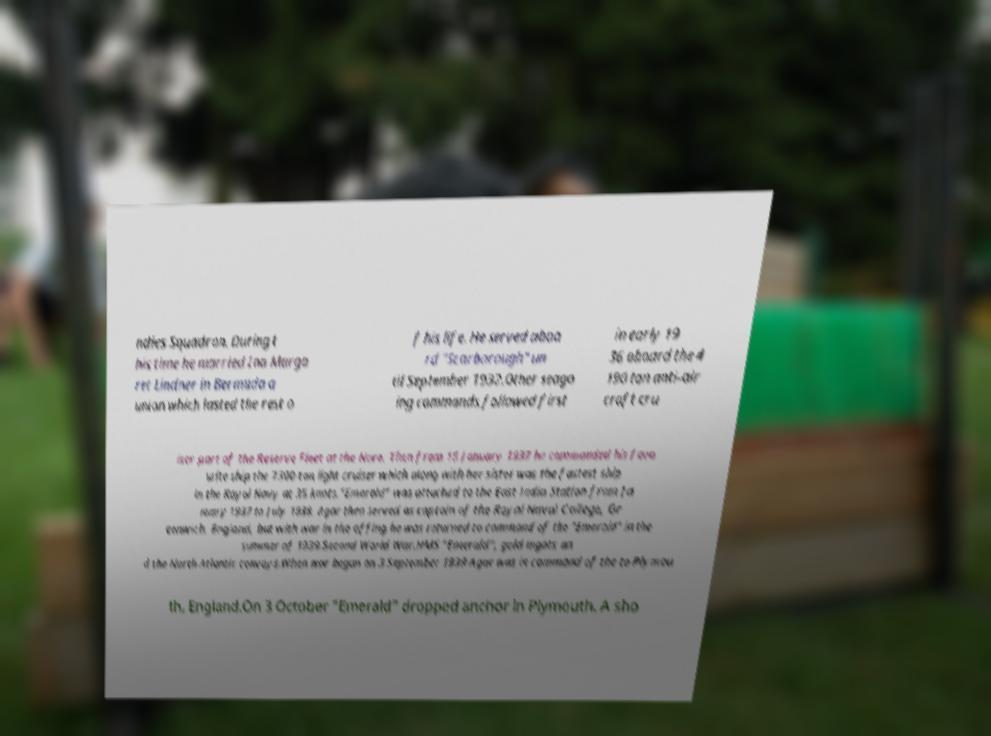Please identify and transcribe the text found in this image. ndies Squadron. During t his time he married Ina Marga ret Lindner in Bermuda a union which lasted the rest o f his life. He served aboa rd "Scarborough" un til September 1932.Other seago ing commands followed first in early 19 36 aboard the 4 190 ton anti-air craft cru iser part of the Reserve Fleet at the Nore. Then from 15 January 1937 he commanded his favo urite ship the 7300-ton light cruiser which along with her sister was the fastest ship in the Royal Navy at 35 knots."Emerald" was attached to the East India Station from Ja nuary 1937 to July 1938. Agar then served as captain of the Royal Naval College, Gr eenwich, England, but with war in the offing he was returned to command of the "Emerald" in the summer of 1939.Second World War.HMS "Emerald", gold ingots an d the North Atlantic convoys.When war began on 3 September 1939 Agar was in command of the to Plymou th, England.On 3 October "Emerald" dropped anchor in Plymouth. A sho 